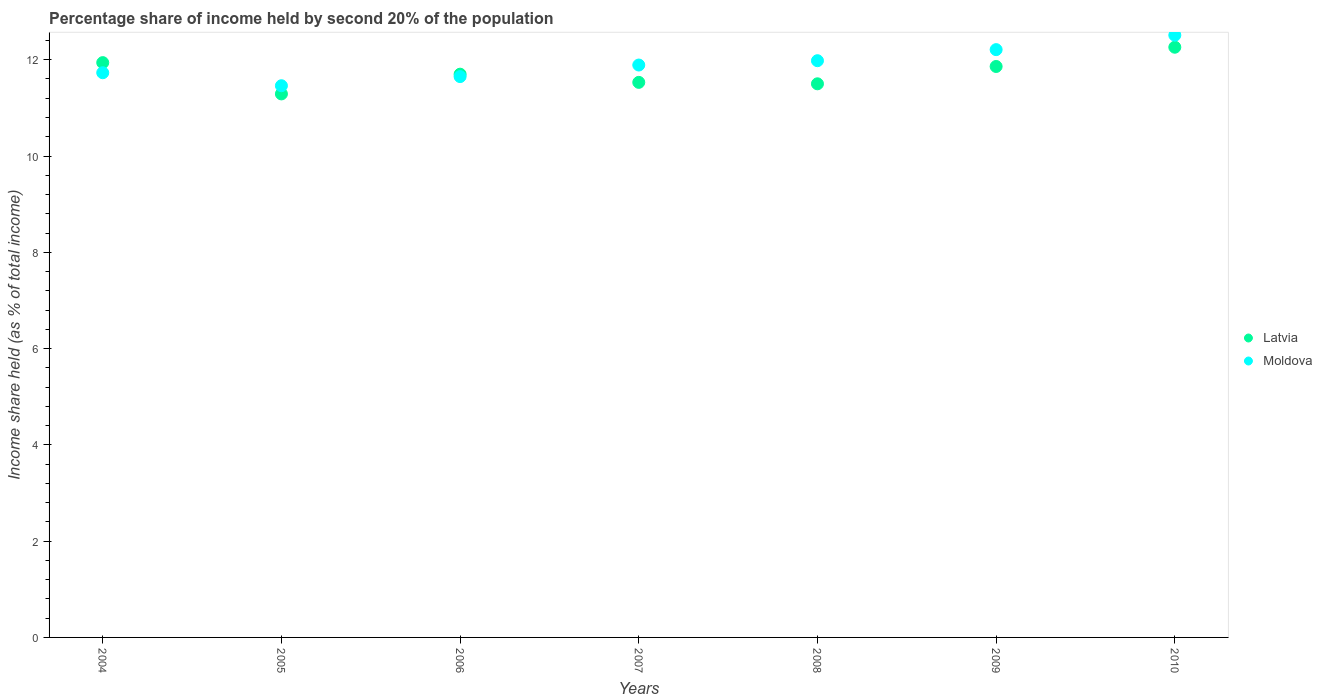Is the number of dotlines equal to the number of legend labels?
Your answer should be compact. Yes. What is the share of income held by second 20% of the population in Moldova in 2010?
Provide a short and direct response. 12.51. Across all years, what is the maximum share of income held by second 20% of the population in Latvia?
Give a very brief answer. 12.26. Across all years, what is the minimum share of income held by second 20% of the population in Latvia?
Make the answer very short. 11.29. In which year was the share of income held by second 20% of the population in Moldova minimum?
Make the answer very short. 2005. What is the total share of income held by second 20% of the population in Moldova in the graph?
Keep it short and to the point. 83.43. What is the difference between the share of income held by second 20% of the population in Latvia in 2007 and that in 2009?
Your response must be concise. -0.33. What is the difference between the share of income held by second 20% of the population in Latvia in 2006 and the share of income held by second 20% of the population in Moldova in 2005?
Ensure brevity in your answer.  0.24. What is the average share of income held by second 20% of the population in Moldova per year?
Offer a terse response. 11.92. In the year 2010, what is the difference between the share of income held by second 20% of the population in Latvia and share of income held by second 20% of the population in Moldova?
Keep it short and to the point. -0.25. In how many years, is the share of income held by second 20% of the population in Latvia greater than 5.2 %?
Make the answer very short. 7. What is the ratio of the share of income held by second 20% of the population in Latvia in 2004 to that in 2010?
Ensure brevity in your answer.  0.97. What is the difference between the highest and the second highest share of income held by second 20% of the population in Moldova?
Your answer should be compact. 0.3. What is the difference between the highest and the lowest share of income held by second 20% of the population in Moldova?
Your answer should be compact. 1.05. Is the share of income held by second 20% of the population in Moldova strictly greater than the share of income held by second 20% of the population in Latvia over the years?
Your response must be concise. No. How many dotlines are there?
Make the answer very short. 2. How many years are there in the graph?
Give a very brief answer. 7. Does the graph contain any zero values?
Provide a succinct answer. No. What is the title of the graph?
Make the answer very short. Percentage share of income held by second 20% of the population. What is the label or title of the X-axis?
Your response must be concise. Years. What is the label or title of the Y-axis?
Make the answer very short. Income share held (as % of total income). What is the Income share held (as % of total income) of Latvia in 2004?
Provide a short and direct response. 11.94. What is the Income share held (as % of total income) in Moldova in 2004?
Provide a short and direct response. 11.73. What is the Income share held (as % of total income) in Latvia in 2005?
Your response must be concise. 11.29. What is the Income share held (as % of total income) in Moldova in 2005?
Provide a short and direct response. 11.46. What is the Income share held (as % of total income) in Latvia in 2006?
Make the answer very short. 11.7. What is the Income share held (as % of total income) in Moldova in 2006?
Your response must be concise. 11.65. What is the Income share held (as % of total income) in Latvia in 2007?
Provide a short and direct response. 11.53. What is the Income share held (as % of total income) in Moldova in 2007?
Offer a very short reply. 11.89. What is the Income share held (as % of total income) of Moldova in 2008?
Offer a terse response. 11.98. What is the Income share held (as % of total income) in Latvia in 2009?
Provide a short and direct response. 11.86. What is the Income share held (as % of total income) of Moldova in 2009?
Make the answer very short. 12.21. What is the Income share held (as % of total income) in Latvia in 2010?
Your response must be concise. 12.26. What is the Income share held (as % of total income) in Moldova in 2010?
Keep it short and to the point. 12.51. Across all years, what is the maximum Income share held (as % of total income) of Latvia?
Offer a very short reply. 12.26. Across all years, what is the maximum Income share held (as % of total income) of Moldova?
Give a very brief answer. 12.51. Across all years, what is the minimum Income share held (as % of total income) in Latvia?
Provide a short and direct response. 11.29. Across all years, what is the minimum Income share held (as % of total income) in Moldova?
Provide a short and direct response. 11.46. What is the total Income share held (as % of total income) in Latvia in the graph?
Your answer should be very brief. 82.08. What is the total Income share held (as % of total income) in Moldova in the graph?
Provide a short and direct response. 83.43. What is the difference between the Income share held (as % of total income) in Latvia in 2004 and that in 2005?
Provide a succinct answer. 0.65. What is the difference between the Income share held (as % of total income) of Moldova in 2004 and that in 2005?
Offer a very short reply. 0.27. What is the difference between the Income share held (as % of total income) in Latvia in 2004 and that in 2006?
Your answer should be compact. 0.24. What is the difference between the Income share held (as % of total income) in Latvia in 2004 and that in 2007?
Keep it short and to the point. 0.41. What is the difference between the Income share held (as % of total income) in Moldova in 2004 and that in 2007?
Your answer should be compact. -0.16. What is the difference between the Income share held (as % of total income) in Latvia in 2004 and that in 2008?
Ensure brevity in your answer.  0.44. What is the difference between the Income share held (as % of total income) of Moldova in 2004 and that in 2008?
Offer a terse response. -0.25. What is the difference between the Income share held (as % of total income) in Latvia in 2004 and that in 2009?
Ensure brevity in your answer.  0.08. What is the difference between the Income share held (as % of total income) of Moldova in 2004 and that in 2009?
Your answer should be compact. -0.48. What is the difference between the Income share held (as % of total income) in Latvia in 2004 and that in 2010?
Offer a terse response. -0.32. What is the difference between the Income share held (as % of total income) in Moldova in 2004 and that in 2010?
Give a very brief answer. -0.78. What is the difference between the Income share held (as % of total income) in Latvia in 2005 and that in 2006?
Your answer should be compact. -0.41. What is the difference between the Income share held (as % of total income) in Moldova in 2005 and that in 2006?
Provide a short and direct response. -0.19. What is the difference between the Income share held (as % of total income) of Latvia in 2005 and that in 2007?
Provide a short and direct response. -0.24. What is the difference between the Income share held (as % of total income) in Moldova in 2005 and that in 2007?
Provide a short and direct response. -0.43. What is the difference between the Income share held (as % of total income) of Latvia in 2005 and that in 2008?
Your answer should be compact. -0.21. What is the difference between the Income share held (as % of total income) in Moldova in 2005 and that in 2008?
Provide a succinct answer. -0.52. What is the difference between the Income share held (as % of total income) in Latvia in 2005 and that in 2009?
Make the answer very short. -0.57. What is the difference between the Income share held (as % of total income) in Moldova in 2005 and that in 2009?
Give a very brief answer. -0.75. What is the difference between the Income share held (as % of total income) of Latvia in 2005 and that in 2010?
Provide a succinct answer. -0.97. What is the difference between the Income share held (as % of total income) of Moldova in 2005 and that in 2010?
Provide a short and direct response. -1.05. What is the difference between the Income share held (as % of total income) of Latvia in 2006 and that in 2007?
Your response must be concise. 0.17. What is the difference between the Income share held (as % of total income) in Moldova in 2006 and that in 2007?
Offer a terse response. -0.24. What is the difference between the Income share held (as % of total income) in Latvia in 2006 and that in 2008?
Provide a succinct answer. 0.2. What is the difference between the Income share held (as % of total income) in Moldova in 2006 and that in 2008?
Give a very brief answer. -0.33. What is the difference between the Income share held (as % of total income) in Latvia in 2006 and that in 2009?
Your answer should be compact. -0.16. What is the difference between the Income share held (as % of total income) in Moldova in 2006 and that in 2009?
Provide a short and direct response. -0.56. What is the difference between the Income share held (as % of total income) in Latvia in 2006 and that in 2010?
Provide a short and direct response. -0.56. What is the difference between the Income share held (as % of total income) in Moldova in 2006 and that in 2010?
Your response must be concise. -0.86. What is the difference between the Income share held (as % of total income) of Latvia in 2007 and that in 2008?
Your response must be concise. 0.03. What is the difference between the Income share held (as % of total income) of Moldova in 2007 and that in 2008?
Make the answer very short. -0.09. What is the difference between the Income share held (as % of total income) of Latvia in 2007 and that in 2009?
Offer a terse response. -0.33. What is the difference between the Income share held (as % of total income) of Moldova in 2007 and that in 2009?
Give a very brief answer. -0.32. What is the difference between the Income share held (as % of total income) of Latvia in 2007 and that in 2010?
Ensure brevity in your answer.  -0.73. What is the difference between the Income share held (as % of total income) of Moldova in 2007 and that in 2010?
Make the answer very short. -0.62. What is the difference between the Income share held (as % of total income) in Latvia in 2008 and that in 2009?
Your answer should be very brief. -0.36. What is the difference between the Income share held (as % of total income) of Moldova in 2008 and that in 2009?
Your answer should be compact. -0.23. What is the difference between the Income share held (as % of total income) of Latvia in 2008 and that in 2010?
Your answer should be compact. -0.76. What is the difference between the Income share held (as % of total income) of Moldova in 2008 and that in 2010?
Offer a very short reply. -0.53. What is the difference between the Income share held (as % of total income) of Latvia in 2009 and that in 2010?
Your answer should be very brief. -0.4. What is the difference between the Income share held (as % of total income) of Moldova in 2009 and that in 2010?
Your answer should be very brief. -0.3. What is the difference between the Income share held (as % of total income) of Latvia in 2004 and the Income share held (as % of total income) of Moldova in 2005?
Provide a short and direct response. 0.48. What is the difference between the Income share held (as % of total income) in Latvia in 2004 and the Income share held (as % of total income) in Moldova in 2006?
Offer a very short reply. 0.29. What is the difference between the Income share held (as % of total income) of Latvia in 2004 and the Income share held (as % of total income) of Moldova in 2007?
Provide a succinct answer. 0.05. What is the difference between the Income share held (as % of total income) in Latvia in 2004 and the Income share held (as % of total income) in Moldova in 2008?
Your answer should be very brief. -0.04. What is the difference between the Income share held (as % of total income) in Latvia in 2004 and the Income share held (as % of total income) in Moldova in 2009?
Provide a short and direct response. -0.27. What is the difference between the Income share held (as % of total income) in Latvia in 2004 and the Income share held (as % of total income) in Moldova in 2010?
Offer a very short reply. -0.57. What is the difference between the Income share held (as % of total income) of Latvia in 2005 and the Income share held (as % of total income) of Moldova in 2006?
Give a very brief answer. -0.36. What is the difference between the Income share held (as % of total income) of Latvia in 2005 and the Income share held (as % of total income) of Moldova in 2008?
Offer a very short reply. -0.69. What is the difference between the Income share held (as % of total income) in Latvia in 2005 and the Income share held (as % of total income) in Moldova in 2009?
Your answer should be very brief. -0.92. What is the difference between the Income share held (as % of total income) in Latvia in 2005 and the Income share held (as % of total income) in Moldova in 2010?
Ensure brevity in your answer.  -1.22. What is the difference between the Income share held (as % of total income) of Latvia in 2006 and the Income share held (as % of total income) of Moldova in 2007?
Your answer should be very brief. -0.19. What is the difference between the Income share held (as % of total income) in Latvia in 2006 and the Income share held (as % of total income) in Moldova in 2008?
Your answer should be very brief. -0.28. What is the difference between the Income share held (as % of total income) of Latvia in 2006 and the Income share held (as % of total income) of Moldova in 2009?
Make the answer very short. -0.51. What is the difference between the Income share held (as % of total income) in Latvia in 2006 and the Income share held (as % of total income) in Moldova in 2010?
Offer a very short reply. -0.81. What is the difference between the Income share held (as % of total income) in Latvia in 2007 and the Income share held (as % of total income) in Moldova in 2008?
Give a very brief answer. -0.45. What is the difference between the Income share held (as % of total income) in Latvia in 2007 and the Income share held (as % of total income) in Moldova in 2009?
Keep it short and to the point. -0.68. What is the difference between the Income share held (as % of total income) in Latvia in 2007 and the Income share held (as % of total income) in Moldova in 2010?
Make the answer very short. -0.98. What is the difference between the Income share held (as % of total income) of Latvia in 2008 and the Income share held (as % of total income) of Moldova in 2009?
Keep it short and to the point. -0.71. What is the difference between the Income share held (as % of total income) in Latvia in 2008 and the Income share held (as % of total income) in Moldova in 2010?
Ensure brevity in your answer.  -1.01. What is the difference between the Income share held (as % of total income) in Latvia in 2009 and the Income share held (as % of total income) in Moldova in 2010?
Keep it short and to the point. -0.65. What is the average Income share held (as % of total income) in Latvia per year?
Offer a terse response. 11.73. What is the average Income share held (as % of total income) in Moldova per year?
Your answer should be very brief. 11.92. In the year 2004, what is the difference between the Income share held (as % of total income) in Latvia and Income share held (as % of total income) in Moldova?
Provide a short and direct response. 0.21. In the year 2005, what is the difference between the Income share held (as % of total income) of Latvia and Income share held (as % of total income) of Moldova?
Ensure brevity in your answer.  -0.17. In the year 2007, what is the difference between the Income share held (as % of total income) of Latvia and Income share held (as % of total income) of Moldova?
Offer a terse response. -0.36. In the year 2008, what is the difference between the Income share held (as % of total income) of Latvia and Income share held (as % of total income) of Moldova?
Provide a succinct answer. -0.48. In the year 2009, what is the difference between the Income share held (as % of total income) of Latvia and Income share held (as % of total income) of Moldova?
Your response must be concise. -0.35. In the year 2010, what is the difference between the Income share held (as % of total income) in Latvia and Income share held (as % of total income) in Moldova?
Give a very brief answer. -0.25. What is the ratio of the Income share held (as % of total income) of Latvia in 2004 to that in 2005?
Provide a short and direct response. 1.06. What is the ratio of the Income share held (as % of total income) in Moldova in 2004 to that in 2005?
Offer a terse response. 1.02. What is the ratio of the Income share held (as % of total income) in Latvia in 2004 to that in 2006?
Your answer should be very brief. 1.02. What is the ratio of the Income share held (as % of total income) in Moldova in 2004 to that in 2006?
Offer a terse response. 1.01. What is the ratio of the Income share held (as % of total income) in Latvia in 2004 to that in 2007?
Keep it short and to the point. 1.04. What is the ratio of the Income share held (as % of total income) of Moldova in 2004 to that in 2007?
Give a very brief answer. 0.99. What is the ratio of the Income share held (as % of total income) in Latvia in 2004 to that in 2008?
Your answer should be very brief. 1.04. What is the ratio of the Income share held (as % of total income) of Moldova in 2004 to that in 2008?
Provide a succinct answer. 0.98. What is the ratio of the Income share held (as % of total income) in Latvia in 2004 to that in 2009?
Make the answer very short. 1.01. What is the ratio of the Income share held (as % of total income) in Moldova in 2004 to that in 2009?
Ensure brevity in your answer.  0.96. What is the ratio of the Income share held (as % of total income) in Latvia in 2004 to that in 2010?
Your response must be concise. 0.97. What is the ratio of the Income share held (as % of total income) in Moldova in 2004 to that in 2010?
Your response must be concise. 0.94. What is the ratio of the Income share held (as % of total income) in Moldova in 2005 to that in 2006?
Give a very brief answer. 0.98. What is the ratio of the Income share held (as % of total income) of Latvia in 2005 to that in 2007?
Keep it short and to the point. 0.98. What is the ratio of the Income share held (as % of total income) of Moldova in 2005 to that in 2007?
Provide a succinct answer. 0.96. What is the ratio of the Income share held (as % of total income) of Latvia in 2005 to that in 2008?
Provide a short and direct response. 0.98. What is the ratio of the Income share held (as % of total income) of Moldova in 2005 to that in 2008?
Your answer should be very brief. 0.96. What is the ratio of the Income share held (as % of total income) of Latvia in 2005 to that in 2009?
Provide a short and direct response. 0.95. What is the ratio of the Income share held (as % of total income) in Moldova in 2005 to that in 2009?
Your answer should be very brief. 0.94. What is the ratio of the Income share held (as % of total income) in Latvia in 2005 to that in 2010?
Your response must be concise. 0.92. What is the ratio of the Income share held (as % of total income) in Moldova in 2005 to that in 2010?
Provide a succinct answer. 0.92. What is the ratio of the Income share held (as % of total income) in Latvia in 2006 to that in 2007?
Ensure brevity in your answer.  1.01. What is the ratio of the Income share held (as % of total income) in Moldova in 2006 to that in 2007?
Offer a terse response. 0.98. What is the ratio of the Income share held (as % of total income) of Latvia in 2006 to that in 2008?
Offer a terse response. 1.02. What is the ratio of the Income share held (as % of total income) in Moldova in 2006 to that in 2008?
Give a very brief answer. 0.97. What is the ratio of the Income share held (as % of total income) of Latvia in 2006 to that in 2009?
Provide a short and direct response. 0.99. What is the ratio of the Income share held (as % of total income) of Moldova in 2006 to that in 2009?
Offer a very short reply. 0.95. What is the ratio of the Income share held (as % of total income) in Latvia in 2006 to that in 2010?
Offer a terse response. 0.95. What is the ratio of the Income share held (as % of total income) in Moldova in 2006 to that in 2010?
Give a very brief answer. 0.93. What is the ratio of the Income share held (as % of total income) of Latvia in 2007 to that in 2009?
Ensure brevity in your answer.  0.97. What is the ratio of the Income share held (as % of total income) of Moldova in 2007 to that in 2009?
Offer a terse response. 0.97. What is the ratio of the Income share held (as % of total income) of Latvia in 2007 to that in 2010?
Your answer should be very brief. 0.94. What is the ratio of the Income share held (as % of total income) of Moldova in 2007 to that in 2010?
Provide a succinct answer. 0.95. What is the ratio of the Income share held (as % of total income) of Latvia in 2008 to that in 2009?
Ensure brevity in your answer.  0.97. What is the ratio of the Income share held (as % of total income) in Moldova in 2008 to that in 2009?
Ensure brevity in your answer.  0.98. What is the ratio of the Income share held (as % of total income) of Latvia in 2008 to that in 2010?
Provide a short and direct response. 0.94. What is the ratio of the Income share held (as % of total income) in Moldova in 2008 to that in 2010?
Provide a succinct answer. 0.96. What is the ratio of the Income share held (as % of total income) of Latvia in 2009 to that in 2010?
Your response must be concise. 0.97. What is the difference between the highest and the second highest Income share held (as % of total income) of Latvia?
Provide a succinct answer. 0.32. What is the difference between the highest and the lowest Income share held (as % of total income) in Latvia?
Offer a very short reply. 0.97. What is the difference between the highest and the lowest Income share held (as % of total income) of Moldova?
Your response must be concise. 1.05. 